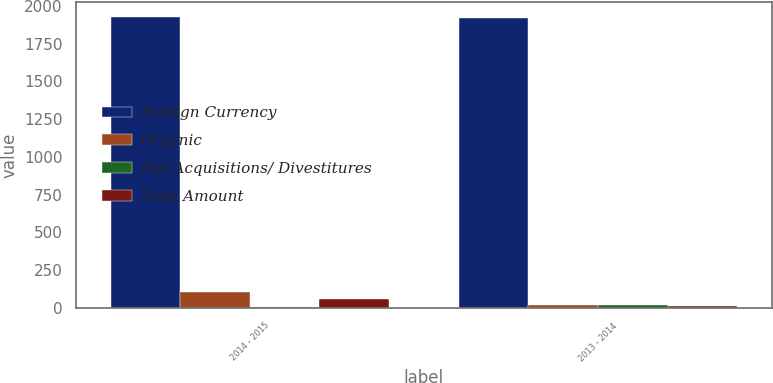<chart> <loc_0><loc_0><loc_500><loc_500><stacked_bar_chart><ecel><fcel>2014 - 2015<fcel>2013 - 2014<nl><fcel>Foreign Currency<fcel>1928.1<fcel>1917.9<nl><fcel>Organic<fcel>101.7<fcel>19.7<nl><fcel>Net Acquisitions/ Divestitures<fcel>3.2<fcel>20.1<nl><fcel>Total Amount<fcel>55.4<fcel>9.8<nl></chart> 